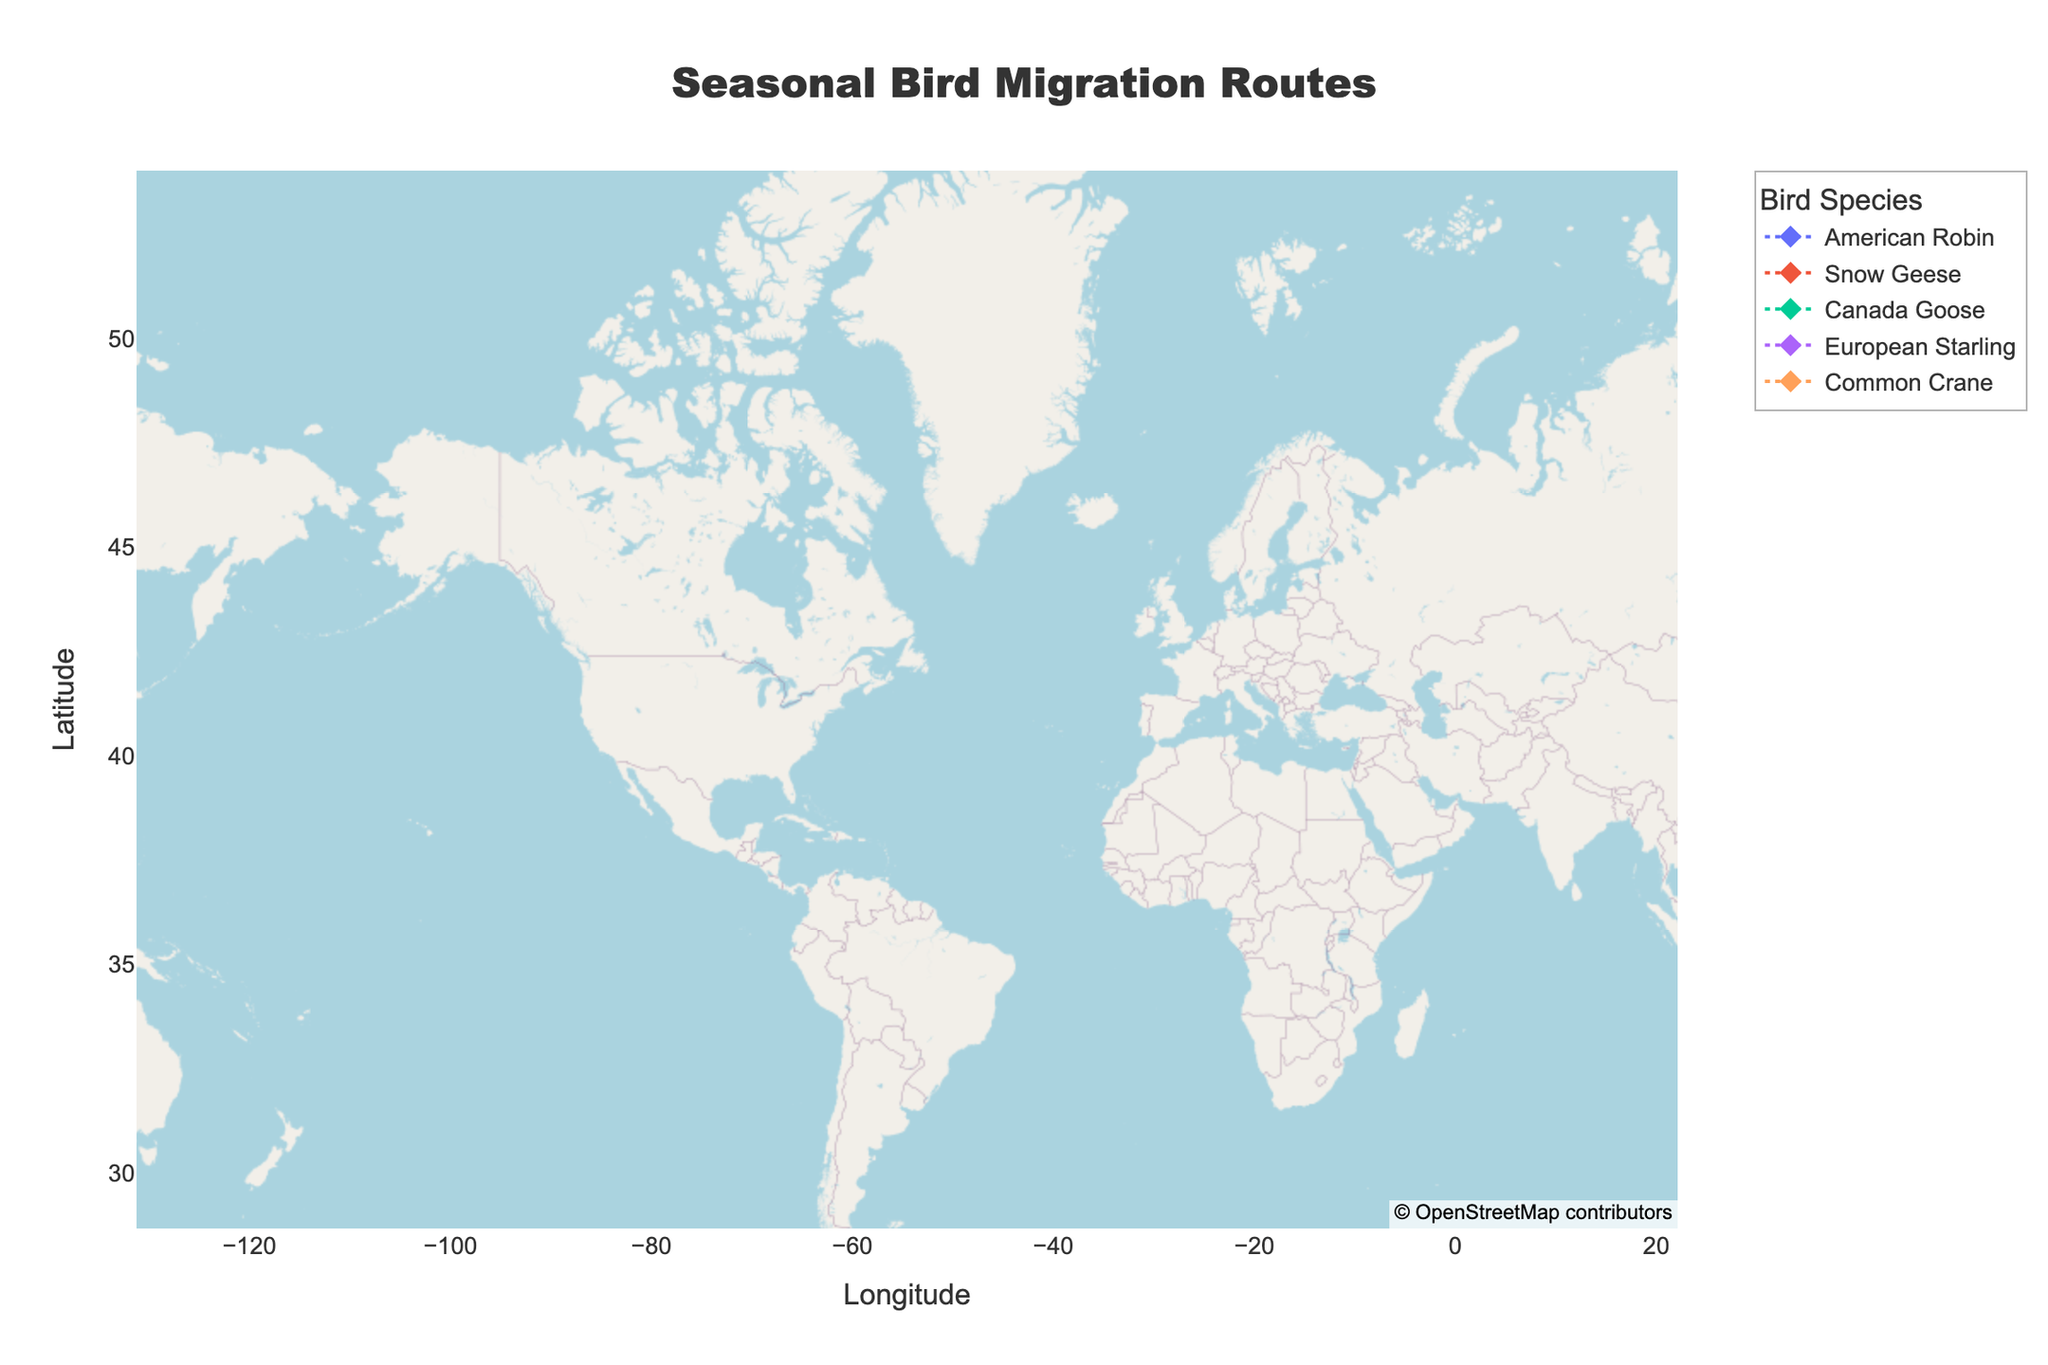Which bird species has a migration route from Fraser Delta to California? According to the hover text, the Snow Geese have a migration route from Fraser Delta to California during the winter season.
Answer: Snow Geese What are the migration destinations of the Common Crane? By examining the hover text for the Common Crane, it shows that they migrate from Berlin to France in the winter and then from France back to Berlin in the spring.
Answer: France, Berlin How many bird species are tracked in this plot? Looking at the legend in the plot, we see the names of the tracked bird species: American Robin, Snow Geese, Canada Goose, European Starling, and Common Crane.
Answer: 5 Is there a bird species that migrates between two international locations? If so, which one? By reviewing the hover text, we see that the European Starling migrates between London and Spain, which are international locations.
Answer: European Starling Which season shows the migration from Mexico to Minneapolis for the American Robin? The hover text for the American Robin indicates that they migrate from Mexico to Minneapolis during the spring season.
Answer: Spring Which bird species migrates between New York and Virginia? According to the hover text and the migration paths, the Canada Goose migrates between New York and Virginia.
Answer: Canada Goose Which bird species has the highest latitude during their migration? By observing the latitude values in the figure, the Common Crane has the highest latitude when in Berlin (52.5°).
Answer: Common Crane Between American Robin and Canadian Goose, which has a migration route involving Mexico? The hover text shows that the American Robin migrates between Minneapolis and Mexico, while the Canada Goose does not have a route involving Mexico.
Answer: American Robin 